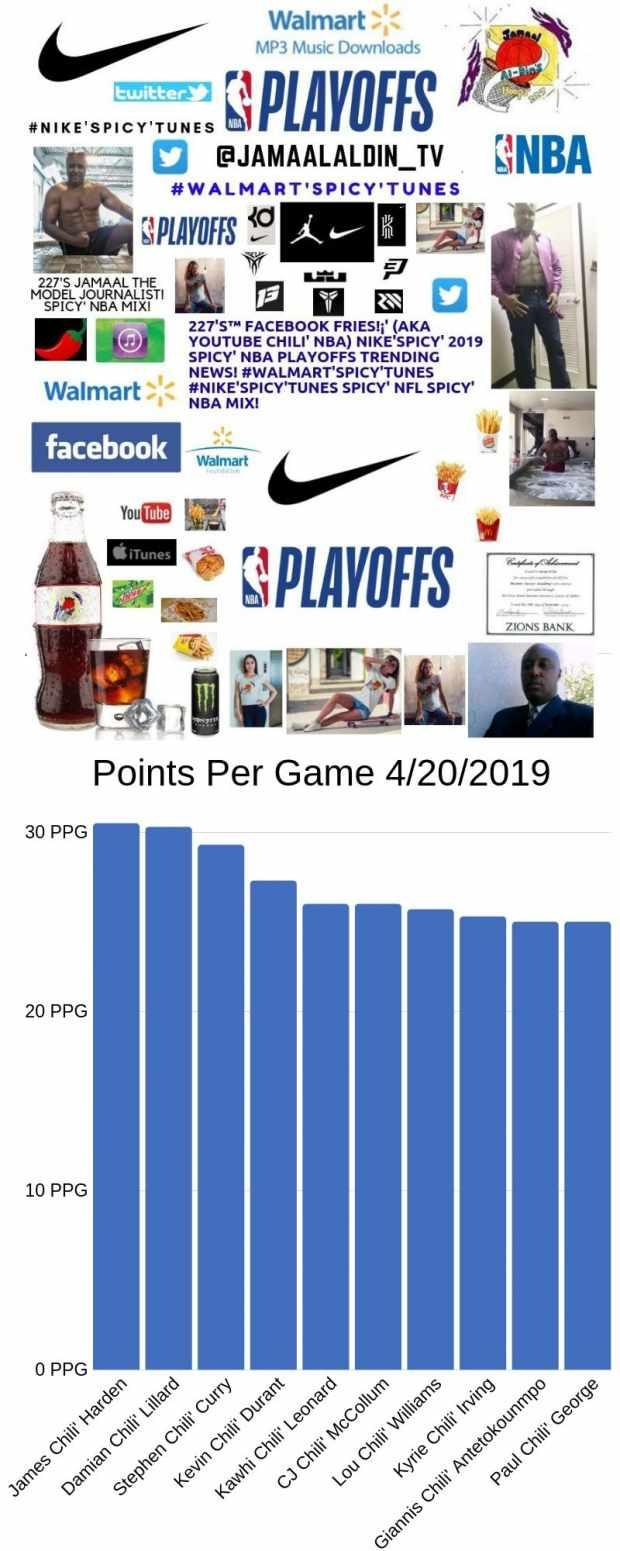Indicate a few pertinent items in this graphic. The top three players in terms of points per game are James Harden, Damian Lillard, and Stephen Curry. 